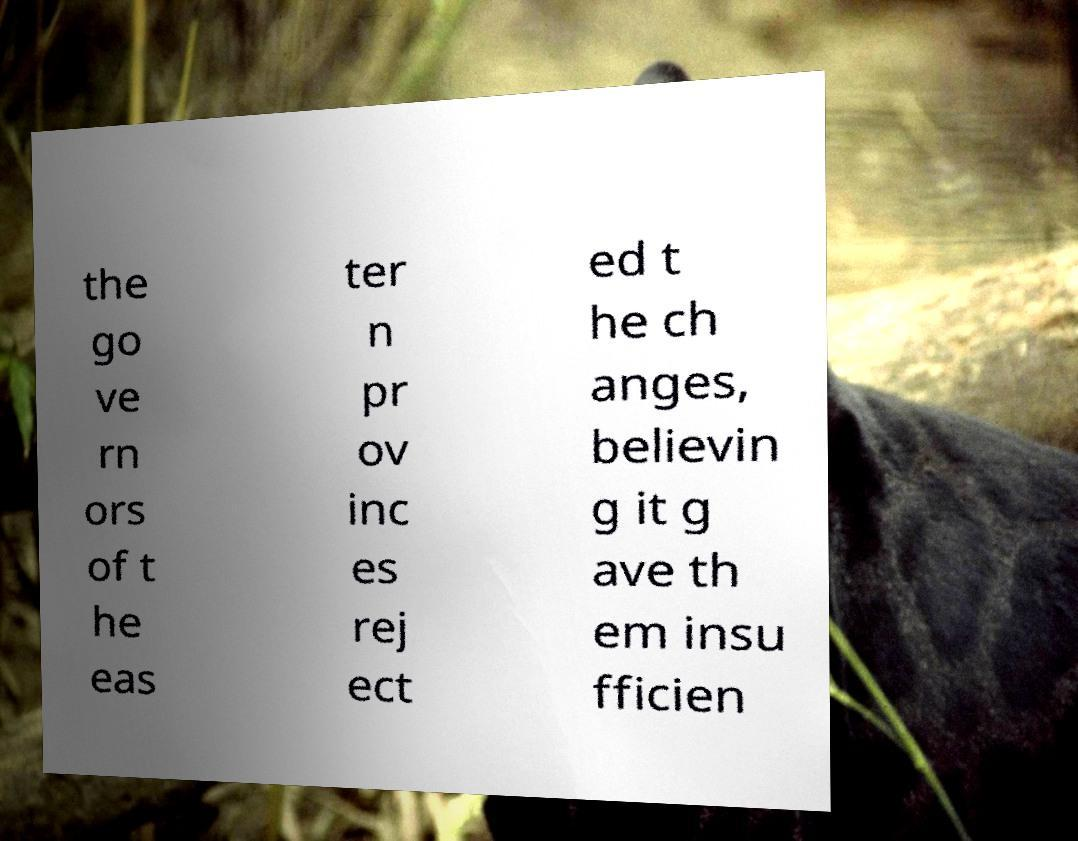Please identify and transcribe the text found in this image. the go ve rn ors of t he eas ter n pr ov inc es rej ect ed t he ch anges, believin g it g ave th em insu fficien 